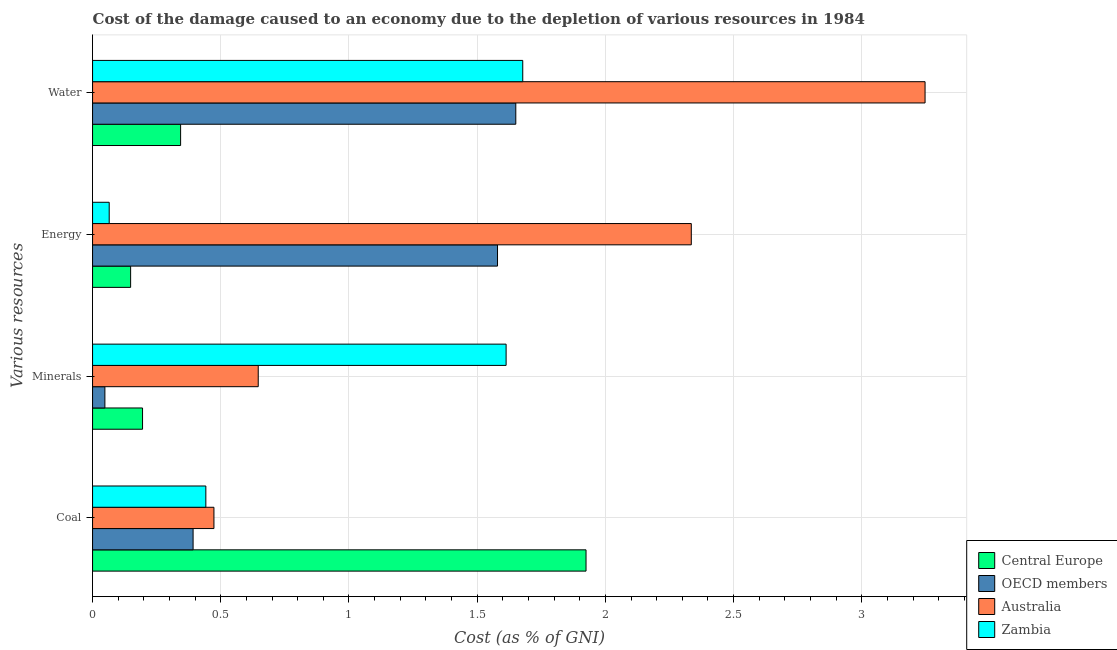How many different coloured bars are there?
Make the answer very short. 4. How many groups of bars are there?
Provide a succinct answer. 4. Are the number of bars per tick equal to the number of legend labels?
Ensure brevity in your answer.  Yes. Are the number of bars on each tick of the Y-axis equal?
Offer a terse response. Yes. How many bars are there on the 2nd tick from the top?
Your response must be concise. 4. How many bars are there on the 3rd tick from the bottom?
Your response must be concise. 4. What is the label of the 1st group of bars from the top?
Give a very brief answer. Water. What is the cost of damage due to depletion of minerals in OECD members?
Your answer should be compact. 0.05. Across all countries, what is the maximum cost of damage due to depletion of minerals?
Keep it short and to the point. 1.61. Across all countries, what is the minimum cost of damage due to depletion of water?
Provide a short and direct response. 0.34. In which country was the cost of damage due to depletion of energy minimum?
Your answer should be compact. Zambia. What is the total cost of damage due to depletion of coal in the graph?
Offer a very short reply. 3.23. What is the difference between the cost of damage due to depletion of water in Australia and that in Zambia?
Give a very brief answer. 1.57. What is the difference between the cost of damage due to depletion of energy in OECD members and the cost of damage due to depletion of minerals in Australia?
Give a very brief answer. 0.93. What is the average cost of damage due to depletion of energy per country?
Offer a terse response. 1.03. What is the difference between the cost of damage due to depletion of water and cost of damage due to depletion of coal in Zambia?
Provide a succinct answer. 1.24. In how many countries, is the cost of damage due to depletion of minerals greater than 1.1 %?
Offer a terse response. 1. What is the ratio of the cost of damage due to depletion of coal in Central Europe to that in Australia?
Your answer should be very brief. 4.07. Is the difference between the cost of damage due to depletion of energy in OECD members and Central Europe greater than the difference between the cost of damage due to depletion of water in OECD members and Central Europe?
Your response must be concise. Yes. What is the difference between the highest and the second highest cost of damage due to depletion of minerals?
Offer a very short reply. 0.97. What is the difference between the highest and the lowest cost of damage due to depletion of coal?
Your answer should be compact. 1.53. Is the sum of the cost of damage due to depletion of energy in Australia and Central Europe greater than the maximum cost of damage due to depletion of water across all countries?
Offer a very short reply. No. What does the 4th bar from the top in Minerals represents?
Offer a very short reply. Central Europe. What does the 4th bar from the bottom in Water represents?
Your response must be concise. Zambia. Is it the case that in every country, the sum of the cost of damage due to depletion of coal and cost of damage due to depletion of minerals is greater than the cost of damage due to depletion of energy?
Your answer should be compact. No. How many bars are there?
Your response must be concise. 16. Are all the bars in the graph horizontal?
Your answer should be compact. Yes. Are the values on the major ticks of X-axis written in scientific E-notation?
Offer a terse response. No. Does the graph contain grids?
Provide a succinct answer. Yes. What is the title of the graph?
Provide a short and direct response. Cost of the damage caused to an economy due to the depletion of various resources in 1984 . Does "Heavily indebted poor countries" appear as one of the legend labels in the graph?
Offer a very short reply. No. What is the label or title of the X-axis?
Give a very brief answer. Cost (as % of GNI). What is the label or title of the Y-axis?
Keep it short and to the point. Various resources. What is the Cost (as % of GNI) of Central Europe in Coal?
Your answer should be compact. 1.92. What is the Cost (as % of GNI) in OECD members in Coal?
Give a very brief answer. 0.39. What is the Cost (as % of GNI) of Australia in Coal?
Offer a very short reply. 0.47. What is the Cost (as % of GNI) of Zambia in Coal?
Provide a short and direct response. 0.44. What is the Cost (as % of GNI) in Central Europe in Minerals?
Your answer should be compact. 0.19. What is the Cost (as % of GNI) in OECD members in Minerals?
Keep it short and to the point. 0.05. What is the Cost (as % of GNI) in Australia in Minerals?
Keep it short and to the point. 0.65. What is the Cost (as % of GNI) in Zambia in Minerals?
Keep it short and to the point. 1.61. What is the Cost (as % of GNI) of Central Europe in Energy?
Give a very brief answer. 0.15. What is the Cost (as % of GNI) in OECD members in Energy?
Offer a terse response. 1.58. What is the Cost (as % of GNI) in Australia in Energy?
Ensure brevity in your answer.  2.33. What is the Cost (as % of GNI) in Zambia in Energy?
Offer a terse response. 0.06. What is the Cost (as % of GNI) in Central Europe in Water?
Keep it short and to the point. 0.34. What is the Cost (as % of GNI) of OECD members in Water?
Provide a short and direct response. 1.65. What is the Cost (as % of GNI) of Australia in Water?
Offer a very short reply. 3.25. What is the Cost (as % of GNI) of Zambia in Water?
Keep it short and to the point. 1.68. Across all Various resources, what is the maximum Cost (as % of GNI) of Central Europe?
Your answer should be very brief. 1.92. Across all Various resources, what is the maximum Cost (as % of GNI) in OECD members?
Keep it short and to the point. 1.65. Across all Various resources, what is the maximum Cost (as % of GNI) in Australia?
Offer a very short reply. 3.25. Across all Various resources, what is the maximum Cost (as % of GNI) of Zambia?
Your answer should be very brief. 1.68. Across all Various resources, what is the minimum Cost (as % of GNI) of Central Europe?
Offer a very short reply. 0.15. Across all Various resources, what is the minimum Cost (as % of GNI) of OECD members?
Ensure brevity in your answer.  0.05. Across all Various resources, what is the minimum Cost (as % of GNI) in Australia?
Provide a short and direct response. 0.47. Across all Various resources, what is the minimum Cost (as % of GNI) of Zambia?
Offer a terse response. 0.06. What is the total Cost (as % of GNI) of Central Europe in the graph?
Offer a very short reply. 2.61. What is the total Cost (as % of GNI) in OECD members in the graph?
Give a very brief answer. 3.67. What is the total Cost (as % of GNI) in Australia in the graph?
Your answer should be very brief. 6.7. What is the total Cost (as % of GNI) in Zambia in the graph?
Make the answer very short. 3.8. What is the difference between the Cost (as % of GNI) of Central Europe in Coal and that in Minerals?
Give a very brief answer. 1.73. What is the difference between the Cost (as % of GNI) of OECD members in Coal and that in Minerals?
Your response must be concise. 0.34. What is the difference between the Cost (as % of GNI) of Australia in Coal and that in Minerals?
Ensure brevity in your answer.  -0.17. What is the difference between the Cost (as % of GNI) in Zambia in Coal and that in Minerals?
Keep it short and to the point. -1.17. What is the difference between the Cost (as % of GNI) in Central Europe in Coal and that in Energy?
Provide a succinct answer. 1.78. What is the difference between the Cost (as % of GNI) of OECD members in Coal and that in Energy?
Make the answer very short. -1.19. What is the difference between the Cost (as % of GNI) of Australia in Coal and that in Energy?
Your answer should be very brief. -1.86. What is the difference between the Cost (as % of GNI) of Zambia in Coal and that in Energy?
Your answer should be compact. 0.38. What is the difference between the Cost (as % of GNI) in Central Europe in Coal and that in Water?
Your response must be concise. 1.58. What is the difference between the Cost (as % of GNI) of OECD members in Coal and that in Water?
Keep it short and to the point. -1.26. What is the difference between the Cost (as % of GNI) of Australia in Coal and that in Water?
Make the answer very short. -2.77. What is the difference between the Cost (as % of GNI) of Zambia in Coal and that in Water?
Ensure brevity in your answer.  -1.24. What is the difference between the Cost (as % of GNI) in Central Europe in Minerals and that in Energy?
Provide a succinct answer. 0.05. What is the difference between the Cost (as % of GNI) of OECD members in Minerals and that in Energy?
Your response must be concise. -1.53. What is the difference between the Cost (as % of GNI) in Australia in Minerals and that in Energy?
Make the answer very short. -1.69. What is the difference between the Cost (as % of GNI) in Zambia in Minerals and that in Energy?
Give a very brief answer. 1.55. What is the difference between the Cost (as % of GNI) in Central Europe in Minerals and that in Water?
Offer a terse response. -0.15. What is the difference between the Cost (as % of GNI) in OECD members in Minerals and that in Water?
Keep it short and to the point. -1.6. What is the difference between the Cost (as % of GNI) of Australia in Minerals and that in Water?
Your answer should be compact. -2.6. What is the difference between the Cost (as % of GNI) in Zambia in Minerals and that in Water?
Offer a terse response. -0.06. What is the difference between the Cost (as % of GNI) of Central Europe in Energy and that in Water?
Provide a short and direct response. -0.19. What is the difference between the Cost (as % of GNI) in OECD members in Energy and that in Water?
Your answer should be very brief. -0.07. What is the difference between the Cost (as % of GNI) in Australia in Energy and that in Water?
Ensure brevity in your answer.  -0.91. What is the difference between the Cost (as % of GNI) in Zambia in Energy and that in Water?
Your answer should be compact. -1.61. What is the difference between the Cost (as % of GNI) of Central Europe in Coal and the Cost (as % of GNI) of OECD members in Minerals?
Your answer should be compact. 1.88. What is the difference between the Cost (as % of GNI) in Central Europe in Coal and the Cost (as % of GNI) in Australia in Minerals?
Give a very brief answer. 1.28. What is the difference between the Cost (as % of GNI) of Central Europe in Coal and the Cost (as % of GNI) of Zambia in Minerals?
Provide a short and direct response. 0.31. What is the difference between the Cost (as % of GNI) in OECD members in Coal and the Cost (as % of GNI) in Australia in Minerals?
Your answer should be compact. -0.25. What is the difference between the Cost (as % of GNI) in OECD members in Coal and the Cost (as % of GNI) in Zambia in Minerals?
Provide a short and direct response. -1.22. What is the difference between the Cost (as % of GNI) of Australia in Coal and the Cost (as % of GNI) of Zambia in Minerals?
Offer a terse response. -1.14. What is the difference between the Cost (as % of GNI) of Central Europe in Coal and the Cost (as % of GNI) of OECD members in Energy?
Make the answer very short. 0.35. What is the difference between the Cost (as % of GNI) in Central Europe in Coal and the Cost (as % of GNI) in Australia in Energy?
Your answer should be compact. -0.41. What is the difference between the Cost (as % of GNI) in Central Europe in Coal and the Cost (as % of GNI) in Zambia in Energy?
Provide a short and direct response. 1.86. What is the difference between the Cost (as % of GNI) in OECD members in Coal and the Cost (as % of GNI) in Australia in Energy?
Ensure brevity in your answer.  -1.94. What is the difference between the Cost (as % of GNI) of OECD members in Coal and the Cost (as % of GNI) of Zambia in Energy?
Ensure brevity in your answer.  0.33. What is the difference between the Cost (as % of GNI) in Australia in Coal and the Cost (as % of GNI) in Zambia in Energy?
Keep it short and to the point. 0.41. What is the difference between the Cost (as % of GNI) in Central Europe in Coal and the Cost (as % of GNI) in OECD members in Water?
Your response must be concise. 0.27. What is the difference between the Cost (as % of GNI) of Central Europe in Coal and the Cost (as % of GNI) of Australia in Water?
Your response must be concise. -1.32. What is the difference between the Cost (as % of GNI) in Central Europe in Coal and the Cost (as % of GNI) in Zambia in Water?
Provide a short and direct response. 0.25. What is the difference between the Cost (as % of GNI) in OECD members in Coal and the Cost (as % of GNI) in Australia in Water?
Keep it short and to the point. -2.85. What is the difference between the Cost (as % of GNI) of OECD members in Coal and the Cost (as % of GNI) of Zambia in Water?
Your answer should be compact. -1.29. What is the difference between the Cost (as % of GNI) of Australia in Coal and the Cost (as % of GNI) of Zambia in Water?
Provide a succinct answer. -1.2. What is the difference between the Cost (as % of GNI) in Central Europe in Minerals and the Cost (as % of GNI) in OECD members in Energy?
Offer a very short reply. -1.38. What is the difference between the Cost (as % of GNI) of Central Europe in Minerals and the Cost (as % of GNI) of Australia in Energy?
Provide a short and direct response. -2.14. What is the difference between the Cost (as % of GNI) in Central Europe in Minerals and the Cost (as % of GNI) in Zambia in Energy?
Your response must be concise. 0.13. What is the difference between the Cost (as % of GNI) of OECD members in Minerals and the Cost (as % of GNI) of Australia in Energy?
Your response must be concise. -2.29. What is the difference between the Cost (as % of GNI) in OECD members in Minerals and the Cost (as % of GNI) in Zambia in Energy?
Your response must be concise. -0.02. What is the difference between the Cost (as % of GNI) in Australia in Minerals and the Cost (as % of GNI) in Zambia in Energy?
Give a very brief answer. 0.58. What is the difference between the Cost (as % of GNI) in Central Europe in Minerals and the Cost (as % of GNI) in OECD members in Water?
Make the answer very short. -1.46. What is the difference between the Cost (as % of GNI) of Central Europe in Minerals and the Cost (as % of GNI) of Australia in Water?
Your response must be concise. -3.05. What is the difference between the Cost (as % of GNI) in Central Europe in Minerals and the Cost (as % of GNI) in Zambia in Water?
Your answer should be very brief. -1.48. What is the difference between the Cost (as % of GNI) of OECD members in Minerals and the Cost (as % of GNI) of Australia in Water?
Provide a succinct answer. -3.2. What is the difference between the Cost (as % of GNI) in OECD members in Minerals and the Cost (as % of GNI) in Zambia in Water?
Your response must be concise. -1.63. What is the difference between the Cost (as % of GNI) of Australia in Minerals and the Cost (as % of GNI) of Zambia in Water?
Your answer should be compact. -1.03. What is the difference between the Cost (as % of GNI) in Central Europe in Energy and the Cost (as % of GNI) in OECD members in Water?
Keep it short and to the point. -1.5. What is the difference between the Cost (as % of GNI) in Central Europe in Energy and the Cost (as % of GNI) in Australia in Water?
Your answer should be very brief. -3.1. What is the difference between the Cost (as % of GNI) of Central Europe in Energy and the Cost (as % of GNI) of Zambia in Water?
Offer a terse response. -1.53. What is the difference between the Cost (as % of GNI) of OECD members in Energy and the Cost (as % of GNI) of Australia in Water?
Give a very brief answer. -1.67. What is the difference between the Cost (as % of GNI) of OECD members in Energy and the Cost (as % of GNI) of Zambia in Water?
Give a very brief answer. -0.1. What is the difference between the Cost (as % of GNI) in Australia in Energy and the Cost (as % of GNI) in Zambia in Water?
Provide a succinct answer. 0.66. What is the average Cost (as % of GNI) in Central Europe per Various resources?
Make the answer very short. 0.65. What is the average Cost (as % of GNI) of OECD members per Various resources?
Ensure brevity in your answer.  0.92. What is the average Cost (as % of GNI) in Australia per Various resources?
Provide a succinct answer. 1.68. What is the average Cost (as % of GNI) of Zambia per Various resources?
Offer a very short reply. 0.95. What is the difference between the Cost (as % of GNI) of Central Europe and Cost (as % of GNI) of OECD members in Coal?
Ensure brevity in your answer.  1.53. What is the difference between the Cost (as % of GNI) of Central Europe and Cost (as % of GNI) of Australia in Coal?
Your answer should be compact. 1.45. What is the difference between the Cost (as % of GNI) of Central Europe and Cost (as % of GNI) of Zambia in Coal?
Offer a very short reply. 1.48. What is the difference between the Cost (as % of GNI) in OECD members and Cost (as % of GNI) in Australia in Coal?
Offer a very short reply. -0.08. What is the difference between the Cost (as % of GNI) of OECD members and Cost (as % of GNI) of Zambia in Coal?
Keep it short and to the point. -0.05. What is the difference between the Cost (as % of GNI) in Australia and Cost (as % of GNI) in Zambia in Coal?
Keep it short and to the point. 0.03. What is the difference between the Cost (as % of GNI) of Central Europe and Cost (as % of GNI) of OECD members in Minerals?
Offer a very short reply. 0.15. What is the difference between the Cost (as % of GNI) of Central Europe and Cost (as % of GNI) of Australia in Minerals?
Your answer should be compact. -0.45. What is the difference between the Cost (as % of GNI) of Central Europe and Cost (as % of GNI) of Zambia in Minerals?
Provide a short and direct response. -1.42. What is the difference between the Cost (as % of GNI) in OECD members and Cost (as % of GNI) in Australia in Minerals?
Offer a very short reply. -0.6. What is the difference between the Cost (as % of GNI) of OECD members and Cost (as % of GNI) of Zambia in Minerals?
Provide a succinct answer. -1.56. What is the difference between the Cost (as % of GNI) in Australia and Cost (as % of GNI) in Zambia in Minerals?
Give a very brief answer. -0.97. What is the difference between the Cost (as % of GNI) in Central Europe and Cost (as % of GNI) in OECD members in Energy?
Make the answer very short. -1.43. What is the difference between the Cost (as % of GNI) of Central Europe and Cost (as % of GNI) of Australia in Energy?
Your answer should be very brief. -2.19. What is the difference between the Cost (as % of GNI) of Central Europe and Cost (as % of GNI) of Zambia in Energy?
Make the answer very short. 0.08. What is the difference between the Cost (as % of GNI) of OECD members and Cost (as % of GNI) of Australia in Energy?
Ensure brevity in your answer.  -0.76. What is the difference between the Cost (as % of GNI) in OECD members and Cost (as % of GNI) in Zambia in Energy?
Your response must be concise. 1.51. What is the difference between the Cost (as % of GNI) in Australia and Cost (as % of GNI) in Zambia in Energy?
Provide a succinct answer. 2.27. What is the difference between the Cost (as % of GNI) of Central Europe and Cost (as % of GNI) of OECD members in Water?
Keep it short and to the point. -1.31. What is the difference between the Cost (as % of GNI) of Central Europe and Cost (as % of GNI) of Australia in Water?
Provide a succinct answer. -2.9. What is the difference between the Cost (as % of GNI) in Central Europe and Cost (as % of GNI) in Zambia in Water?
Your answer should be very brief. -1.33. What is the difference between the Cost (as % of GNI) in OECD members and Cost (as % of GNI) in Australia in Water?
Provide a succinct answer. -1.6. What is the difference between the Cost (as % of GNI) of OECD members and Cost (as % of GNI) of Zambia in Water?
Ensure brevity in your answer.  -0.03. What is the difference between the Cost (as % of GNI) of Australia and Cost (as % of GNI) of Zambia in Water?
Provide a short and direct response. 1.57. What is the ratio of the Cost (as % of GNI) of Central Europe in Coal to that in Minerals?
Provide a succinct answer. 9.87. What is the ratio of the Cost (as % of GNI) in OECD members in Coal to that in Minerals?
Provide a short and direct response. 8.15. What is the ratio of the Cost (as % of GNI) of Australia in Coal to that in Minerals?
Make the answer very short. 0.73. What is the ratio of the Cost (as % of GNI) in Zambia in Coal to that in Minerals?
Provide a short and direct response. 0.27. What is the ratio of the Cost (as % of GNI) in Central Europe in Coal to that in Energy?
Keep it short and to the point. 12.97. What is the ratio of the Cost (as % of GNI) of OECD members in Coal to that in Energy?
Offer a terse response. 0.25. What is the ratio of the Cost (as % of GNI) in Australia in Coal to that in Energy?
Ensure brevity in your answer.  0.2. What is the ratio of the Cost (as % of GNI) of Zambia in Coal to that in Energy?
Offer a terse response. 6.81. What is the ratio of the Cost (as % of GNI) in Central Europe in Coal to that in Water?
Make the answer very short. 5.6. What is the ratio of the Cost (as % of GNI) in OECD members in Coal to that in Water?
Your answer should be compact. 0.24. What is the ratio of the Cost (as % of GNI) in Australia in Coal to that in Water?
Your answer should be compact. 0.15. What is the ratio of the Cost (as % of GNI) of Zambia in Coal to that in Water?
Make the answer very short. 0.26. What is the ratio of the Cost (as % of GNI) in Central Europe in Minerals to that in Energy?
Your answer should be very brief. 1.31. What is the ratio of the Cost (as % of GNI) in OECD members in Minerals to that in Energy?
Your answer should be very brief. 0.03. What is the ratio of the Cost (as % of GNI) in Australia in Minerals to that in Energy?
Keep it short and to the point. 0.28. What is the ratio of the Cost (as % of GNI) in Zambia in Minerals to that in Energy?
Your answer should be compact. 24.86. What is the ratio of the Cost (as % of GNI) in Central Europe in Minerals to that in Water?
Ensure brevity in your answer.  0.57. What is the ratio of the Cost (as % of GNI) in OECD members in Minerals to that in Water?
Give a very brief answer. 0.03. What is the ratio of the Cost (as % of GNI) in Australia in Minerals to that in Water?
Your answer should be compact. 0.2. What is the ratio of the Cost (as % of GNI) in Zambia in Minerals to that in Water?
Keep it short and to the point. 0.96. What is the ratio of the Cost (as % of GNI) in Central Europe in Energy to that in Water?
Give a very brief answer. 0.43. What is the ratio of the Cost (as % of GNI) of OECD members in Energy to that in Water?
Give a very brief answer. 0.96. What is the ratio of the Cost (as % of GNI) in Australia in Energy to that in Water?
Give a very brief answer. 0.72. What is the ratio of the Cost (as % of GNI) in Zambia in Energy to that in Water?
Offer a very short reply. 0.04. What is the difference between the highest and the second highest Cost (as % of GNI) of Central Europe?
Your answer should be compact. 1.58. What is the difference between the highest and the second highest Cost (as % of GNI) of OECD members?
Your answer should be compact. 0.07. What is the difference between the highest and the second highest Cost (as % of GNI) of Australia?
Keep it short and to the point. 0.91. What is the difference between the highest and the second highest Cost (as % of GNI) of Zambia?
Provide a short and direct response. 0.06. What is the difference between the highest and the lowest Cost (as % of GNI) in Central Europe?
Give a very brief answer. 1.78. What is the difference between the highest and the lowest Cost (as % of GNI) in OECD members?
Make the answer very short. 1.6. What is the difference between the highest and the lowest Cost (as % of GNI) of Australia?
Offer a terse response. 2.77. What is the difference between the highest and the lowest Cost (as % of GNI) in Zambia?
Your answer should be very brief. 1.61. 